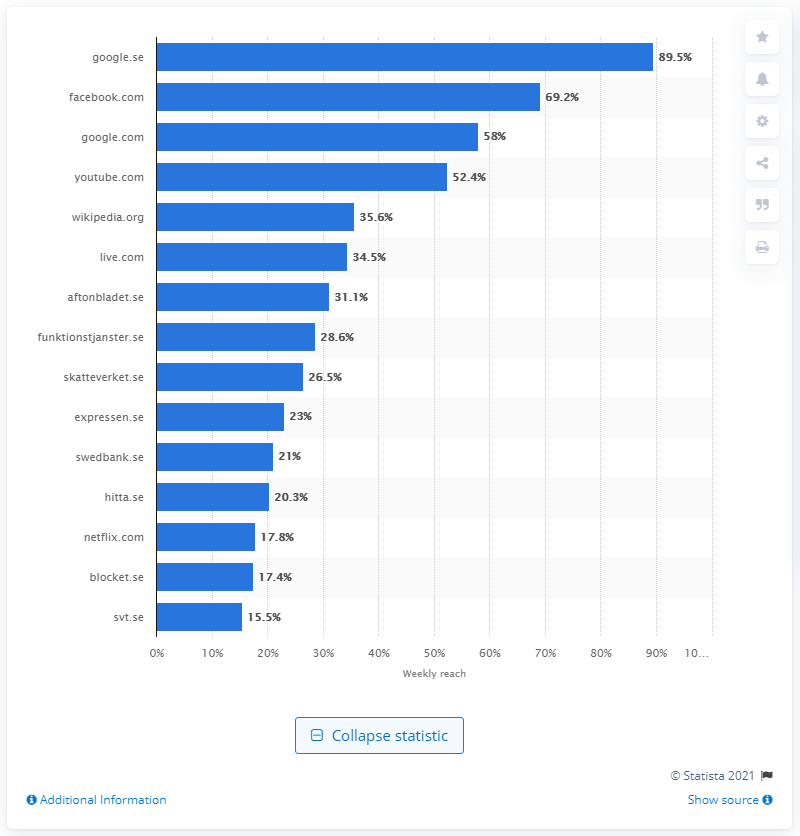List a handful of essential elements in this visual. In 2016, it was reported that 52.4% of people visited YouTube. In March 2017, approximately 58% of internet users visited Google.com. 